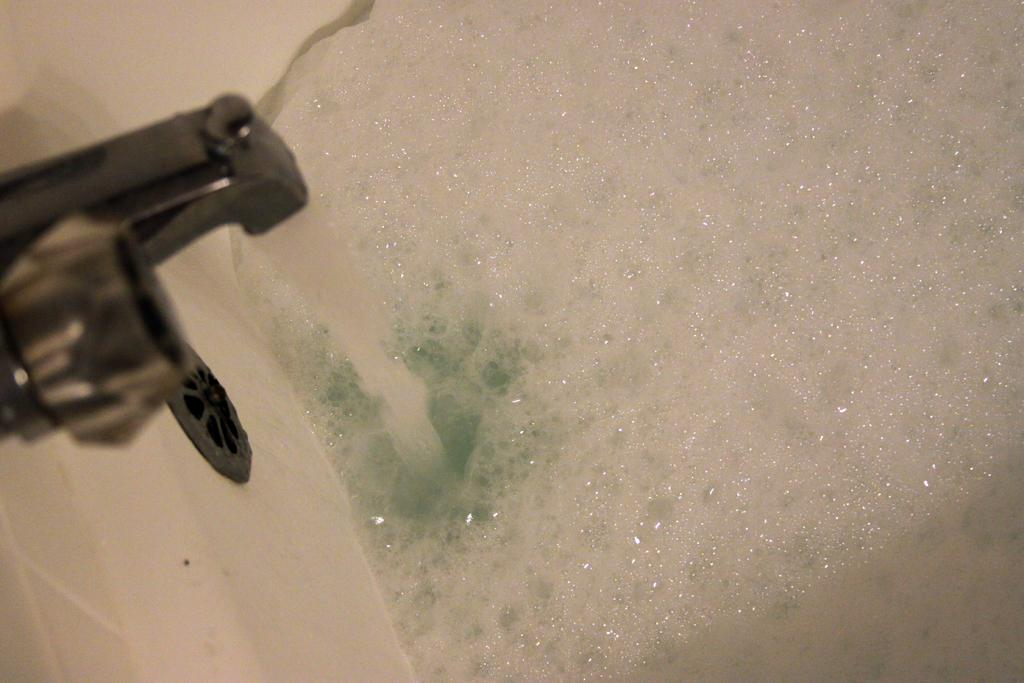What is the main object in the center of the image? There is a tap in the center of the image. What is the liquid substance visible in the image? Water is present in the image. What is the appearance of the substance near the water? There is a foamy substance in the image. Can you describe the color of any objects in the image? There is a black color object and a cream color object in the image. What type of texture does the tap have in the image? The tap itself does not have a texture, as it is a smooth object. 